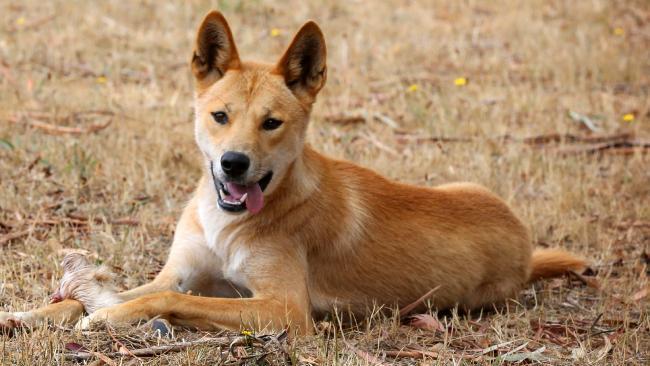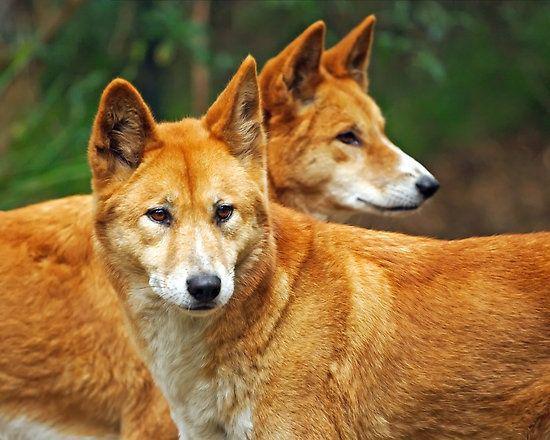The first image is the image on the left, the second image is the image on the right. Examine the images to the left and right. Is the description "There are at most 3 dingos in the image pair" accurate? Answer yes or no. Yes. The first image is the image on the left, the second image is the image on the right. For the images displayed, is the sentence "The right image contains at least two dingoes." factually correct? Answer yes or no. Yes. 